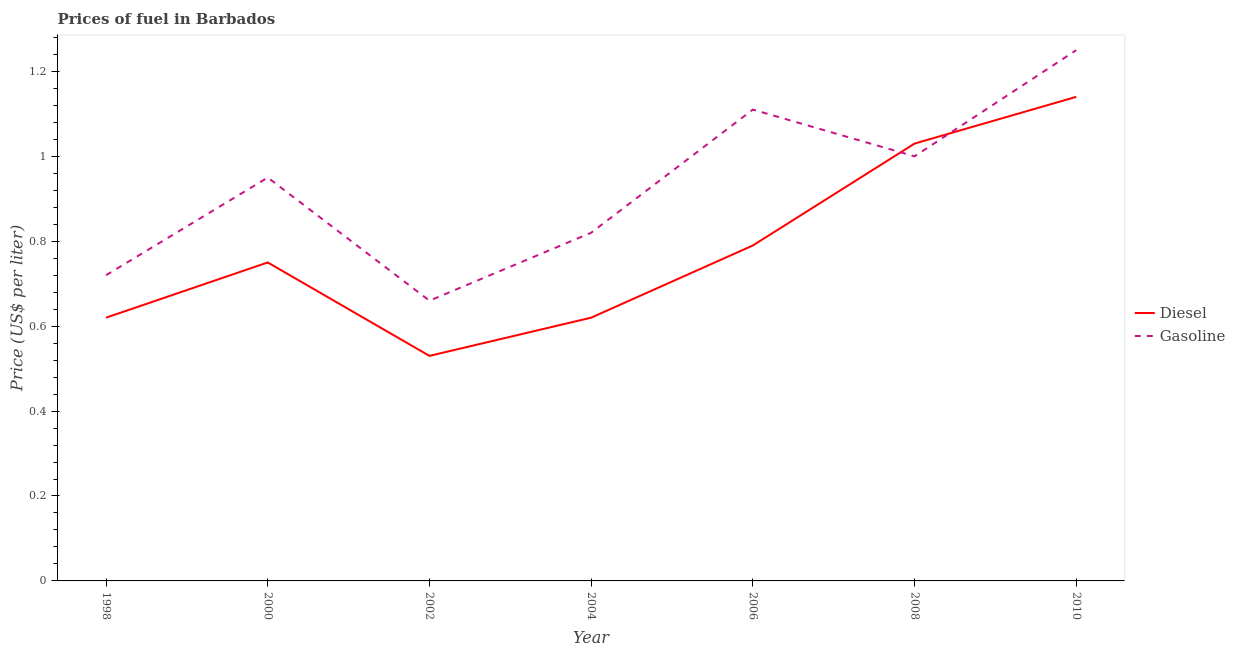How many different coloured lines are there?
Provide a succinct answer. 2. Does the line corresponding to gasoline price intersect with the line corresponding to diesel price?
Keep it short and to the point. Yes. What is the gasoline price in 2008?
Your answer should be very brief. 1. Across all years, what is the maximum diesel price?
Offer a terse response. 1.14. Across all years, what is the minimum diesel price?
Your answer should be compact. 0.53. What is the total diesel price in the graph?
Make the answer very short. 5.48. What is the difference between the diesel price in 2006 and that in 2010?
Provide a short and direct response. -0.35. What is the difference between the diesel price in 2006 and the gasoline price in 2008?
Your answer should be compact. -0.21. What is the average diesel price per year?
Your answer should be compact. 0.78. In the year 2000, what is the difference between the gasoline price and diesel price?
Ensure brevity in your answer.  0.2. In how many years, is the gasoline price greater than 1.04 US$ per litre?
Ensure brevity in your answer.  2. What is the ratio of the diesel price in 2000 to that in 2008?
Offer a very short reply. 0.73. Is the diesel price in 2004 less than that in 2006?
Offer a very short reply. Yes. Is the difference between the gasoline price in 2002 and 2010 greater than the difference between the diesel price in 2002 and 2010?
Ensure brevity in your answer.  Yes. What is the difference between the highest and the second highest gasoline price?
Make the answer very short. 0.14. What is the difference between the highest and the lowest gasoline price?
Your answer should be compact. 0.59. In how many years, is the gasoline price greater than the average gasoline price taken over all years?
Offer a terse response. 4. Is the gasoline price strictly greater than the diesel price over the years?
Offer a terse response. No. Is the gasoline price strictly less than the diesel price over the years?
Your answer should be very brief. No. How many lines are there?
Make the answer very short. 2. How many years are there in the graph?
Ensure brevity in your answer.  7. What is the difference between two consecutive major ticks on the Y-axis?
Offer a very short reply. 0.2. Are the values on the major ticks of Y-axis written in scientific E-notation?
Keep it short and to the point. No. Does the graph contain grids?
Give a very brief answer. No. Where does the legend appear in the graph?
Give a very brief answer. Center right. How many legend labels are there?
Make the answer very short. 2. What is the title of the graph?
Your answer should be very brief. Prices of fuel in Barbados. Does "Taxes on exports" appear as one of the legend labels in the graph?
Offer a very short reply. No. What is the label or title of the X-axis?
Ensure brevity in your answer.  Year. What is the label or title of the Y-axis?
Make the answer very short. Price (US$ per liter). What is the Price (US$ per liter) of Diesel in 1998?
Keep it short and to the point. 0.62. What is the Price (US$ per liter) in Gasoline in 1998?
Make the answer very short. 0.72. What is the Price (US$ per liter) in Diesel in 2002?
Provide a succinct answer. 0.53. What is the Price (US$ per liter) in Gasoline in 2002?
Your response must be concise. 0.66. What is the Price (US$ per liter) in Diesel in 2004?
Offer a terse response. 0.62. What is the Price (US$ per liter) of Gasoline in 2004?
Offer a very short reply. 0.82. What is the Price (US$ per liter) in Diesel in 2006?
Offer a very short reply. 0.79. What is the Price (US$ per liter) in Gasoline in 2006?
Make the answer very short. 1.11. What is the Price (US$ per liter) in Diesel in 2010?
Keep it short and to the point. 1.14. What is the Price (US$ per liter) of Gasoline in 2010?
Your response must be concise. 1.25. Across all years, what is the maximum Price (US$ per liter) of Diesel?
Your response must be concise. 1.14. Across all years, what is the maximum Price (US$ per liter) in Gasoline?
Give a very brief answer. 1.25. Across all years, what is the minimum Price (US$ per liter) in Diesel?
Offer a very short reply. 0.53. Across all years, what is the minimum Price (US$ per liter) of Gasoline?
Your answer should be very brief. 0.66. What is the total Price (US$ per liter) in Diesel in the graph?
Give a very brief answer. 5.48. What is the total Price (US$ per liter) of Gasoline in the graph?
Provide a succinct answer. 6.51. What is the difference between the Price (US$ per liter) in Diesel in 1998 and that in 2000?
Your answer should be compact. -0.13. What is the difference between the Price (US$ per liter) of Gasoline in 1998 and that in 2000?
Provide a succinct answer. -0.23. What is the difference between the Price (US$ per liter) of Diesel in 1998 and that in 2002?
Your response must be concise. 0.09. What is the difference between the Price (US$ per liter) of Diesel in 1998 and that in 2006?
Give a very brief answer. -0.17. What is the difference between the Price (US$ per liter) of Gasoline in 1998 and that in 2006?
Your answer should be very brief. -0.39. What is the difference between the Price (US$ per liter) in Diesel in 1998 and that in 2008?
Provide a short and direct response. -0.41. What is the difference between the Price (US$ per liter) in Gasoline in 1998 and that in 2008?
Provide a short and direct response. -0.28. What is the difference between the Price (US$ per liter) of Diesel in 1998 and that in 2010?
Provide a succinct answer. -0.52. What is the difference between the Price (US$ per liter) in Gasoline in 1998 and that in 2010?
Ensure brevity in your answer.  -0.53. What is the difference between the Price (US$ per liter) of Diesel in 2000 and that in 2002?
Offer a terse response. 0.22. What is the difference between the Price (US$ per liter) in Gasoline in 2000 and that in 2002?
Ensure brevity in your answer.  0.29. What is the difference between the Price (US$ per liter) in Diesel in 2000 and that in 2004?
Your answer should be very brief. 0.13. What is the difference between the Price (US$ per liter) in Gasoline in 2000 and that in 2004?
Your answer should be very brief. 0.13. What is the difference between the Price (US$ per liter) in Diesel in 2000 and that in 2006?
Make the answer very short. -0.04. What is the difference between the Price (US$ per liter) in Gasoline in 2000 and that in 2006?
Keep it short and to the point. -0.16. What is the difference between the Price (US$ per liter) in Diesel in 2000 and that in 2008?
Ensure brevity in your answer.  -0.28. What is the difference between the Price (US$ per liter) in Diesel in 2000 and that in 2010?
Provide a succinct answer. -0.39. What is the difference between the Price (US$ per liter) of Diesel in 2002 and that in 2004?
Offer a terse response. -0.09. What is the difference between the Price (US$ per liter) in Gasoline in 2002 and that in 2004?
Keep it short and to the point. -0.16. What is the difference between the Price (US$ per liter) in Diesel in 2002 and that in 2006?
Give a very brief answer. -0.26. What is the difference between the Price (US$ per liter) in Gasoline in 2002 and that in 2006?
Your answer should be compact. -0.45. What is the difference between the Price (US$ per liter) in Diesel in 2002 and that in 2008?
Keep it short and to the point. -0.5. What is the difference between the Price (US$ per liter) in Gasoline in 2002 and that in 2008?
Provide a succinct answer. -0.34. What is the difference between the Price (US$ per liter) in Diesel in 2002 and that in 2010?
Make the answer very short. -0.61. What is the difference between the Price (US$ per liter) of Gasoline in 2002 and that in 2010?
Your response must be concise. -0.59. What is the difference between the Price (US$ per liter) in Diesel in 2004 and that in 2006?
Your answer should be compact. -0.17. What is the difference between the Price (US$ per liter) of Gasoline in 2004 and that in 2006?
Offer a very short reply. -0.29. What is the difference between the Price (US$ per liter) in Diesel in 2004 and that in 2008?
Offer a very short reply. -0.41. What is the difference between the Price (US$ per liter) of Gasoline in 2004 and that in 2008?
Offer a terse response. -0.18. What is the difference between the Price (US$ per liter) of Diesel in 2004 and that in 2010?
Offer a very short reply. -0.52. What is the difference between the Price (US$ per liter) in Gasoline in 2004 and that in 2010?
Provide a succinct answer. -0.43. What is the difference between the Price (US$ per liter) in Diesel in 2006 and that in 2008?
Provide a short and direct response. -0.24. What is the difference between the Price (US$ per liter) in Gasoline in 2006 and that in 2008?
Give a very brief answer. 0.11. What is the difference between the Price (US$ per liter) of Diesel in 2006 and that in 2010?
Provide a short and direct response. -0.35. What is the difference between the Price (US$ per liter) of Gasoline in 2006 and that in 2010?
Provide a succinct answer. -0.14. What is the difference between the Price (US$ per liter) in Diesel in 2008 and that in 2010?
Give a very brief answer. -0.11. What is the difference between the Price (US$ per liter) in Gasoline in 2008 and that in 2010?
Give a very brief answer. -0.25. What is the difference between the Price (US$ per liter) in Diesel in 1998 and the Price (US$ per liter) in Gasoline in 2000?
Keep it short and to the point. -0.33. What is the difference between the Price (US$ per liter) in Diesel in 1998 and the Price (US$ per liter) in Gasoline in 2002?
Provide a short and direct response. -0.04. What is the difference between the Price (US$ per liter) in Diesel in 1998 and the Price (US$ per liter) in Gasoline in 2004?
Your response must be concise. -0.2. What is the difference between the Price (US$ per liter) in Diesel in 1998 and the Price (US$ per liter) in Gasoline in 2006?
Your response must be concise. -0.49. What is the difference between the Price (US$ per liter) of Diesel in 1998 and the Price (US$ per liter) of Gasoline in 2008?
Your response must be concise. -0.38. What is the difference between the Price (US$ per liter) of Diesel in 1998 and the Price (US$ per liter) of Gasoline in 2010?
Ensure brevity in your answer.  -0.63. What is the difference between the Price (US$ per liter) of Diesel in 2000 and the Price (US$ per liter) of Gasoline in 2002?
Your response must be concise. 0.09. What is the difference between the Price (US$ per liter) of Diesel in 2000 and the Price (US$ per liter) of Gasoline in 2004?
Provide a short and direct response. -0.07. What is the difference between the Price (US$ per liter) of Diesel in 2000 and the Price (US$ per liter) of Gasoline in 2006?
Provide a short and direct response. -0.36. What is the difference between the Price (US$ per liter) in Diesel in 2002 and the Price (US$ per liter) in Gasoline in 2004?
Make the answer very short. -0.29. What is the difference between the Price (US$ per liter) of Diesel in 2002 and the Price (US$ per liter) of Gasoline in 2006?
Provide a succinct answer. -0.58. What is the difference between the Price (US$ per liter) of Diesel in 2002 and the Price (US$ per liter) of Gasoline in 2008?
Give a very brief answer. -0.47. What is the difference between the Price (US$ per liter) in Diesel in 2002 and the Price (US$ per liter) in Gasoline in 2010?
Offer a terse response. -0.72. What is the difference between the Price (US$ per liter) of Diesel in 2004 and the Price (US$ per liter) of Gasoline in 2006?
Keep it short and to the point. -0.49. What is the difference between the Price (US$ per liter) of Diesel in 2004 and the Price (US$ per liter) of Gasoline in 2008?
Give a very brief answer. -0.38. What is the difference between the Price (US$ per liter) of Diesel in 2004 and the Price (US$ per liter) of Gasoline in 2010?
Offer a terse response. -0.63. What is the difference between the Price (US$ per liter) of Diesel in 2006 and the Price (US$ per liter) of Gasoline in 2008?
Your response must be concise. -0.21. What is the difference between the Price (US$ per liter) in Diesel in 2006 and the Price (US$ per liter) in Gasoline in 2010?
Provide a succinct answer. -0.46. What is the difference between the Price (US$ per liter) in Diesel in 2008 and the Price (US$ per liter) in Gasoline in 2010?
Offer a terse response. -0.22. What is the average Price (US$ per liter) of Diesel per year?
Ensure brevity in your answer.  0.78. In the year 2000, what is the difference between the Price (US$ per liter) in Diesel and Price (US$ per liter) in Gasoline?
Your answer should be compact. -0.2. In the year 2002, what is the difference between the Price (US$ per liter) of Diesel and Price (US$ per liter) of Gasoline?
Make the answer very short. -0.13. In the year 2006, what is the difference between the Price (US$ per liter) of Diesel and Price (US$ per liter) of Gasoline?
Provide a succinct answer. -0.32. In the year 2010, what is the difference between the Price (US$ per liter) in Diesel and Price (US$ per liter) in Gasoline?
Keep it short and to the point. -0.11. What is the ratio of the Price (US$ per liter) in Diesel in 1998 to that in 2000?
Ensure brevity in your answer.  0.83. What is the ratio of the Price (US$ per liter) in Gasoline in 1998 to that in 2000?
Give a very brief answer. 0.76. What is the ratio of the Price (US$ per liter) of Diesel in 1998 to that in 2002?
Ensure brevity in your answer.  1.17. What is the ratio of the Price (US$ per liter) in Gasoline in 1998 to that in 2002?
Offer a terse response. 1.09. What is the ratio of the Price (US$ per liter) in Gasoline in 1998 to that in 2004?
Give a very brief answer. 0.88. What is the ratio of the Price (US$ per liter) of Diesel in 1998 to that in 2006?
Ensure brevity in your answer.  0.78. What is the ratio of the Price (US$ per liter) of Gasoline in 1998 to that in 2006?
Your answer should be very brief. 0.65. What is the ratio of the Price (US$ per liter) in Diesel in 1998 to that in 2008?
Provide a succinct answer. 0.6. What is the ratio of the Price (US$ per liter) of Gasoline in 1998 to that in 2008?
Your answer should be very brief. 0.72. What is the ratio of the Price (US$ per liter) of Diesel in 1998 to that in 2010?
Keep it short and to the point. 0.54. What is the ratio of the Price (US$ per liter) in Gasoline in 1998 to that in 2010?
Provide a short and direct response. 0.58. What is the ratio of the Price (US$ per liter) of Diesel in 2000 to that in 2002?
Your answer should be compact. 1.42. What is the ratio of the Price (US$ per liter) of Gasoline in 2000 to that in 2002?
Your response must be concise. 1.44. What is the ratio of the Price (US$ per liter) of Diesel in 2000 to that in 2004?
Provide a short and direct response. 1.21. What is the ratio of the Price (US$ per liter) of Gasoline in 2000 to that in 2004?
Provide a succinct answer. 1.16. What is the ratio of the Price (US$ per liter) of Diesel in 2000 to that in 2006?
Ensure brevity in your answer.  0.95. What is the ratio of the Price (US$ per liter) of Gasoline in 2000 to that in 2006?
Offer a terse response. 0.86. What is the ratio of the Price (US$ per liter) in Diesel in 2000 to that in 2008?
Your response must be concise. 0.73. What is the ratio of the Price (US$ per liter) in Gasoline in 2000 to that in 2008?
Your answer should be very brief. 0.95. What is the ratio of the Price (US$ per liter) in Diesel in 2000 to that in 2010?
Give a very brief answer. 0.66. What is the ratio of the Price (US$ per liter) in Gasoline in 2000 to that in 2010?
Your answer should be compact. 0.76. What is the ratio of the Price (US$ per liter) of Diesel in 2002 to that in 2004?
Your answer should be very brief. 0.85. What is the ratio of the Price (US$ per liter) of Gasoline in 2002 to that in 2004?
Offer a terse response. 0.8. What is the ratio of the Price (US$ per liter) of Diesel in 2002 to that in 2006?
Your answer should be very brief. 0.67. What is the ratio of the Price (US$ per liter) in Gasoline in 2002 to that in 2006?
Offer a terse response. 0.59. What is the ratio of the Price (US$ per liter) of Diesel in 2002 to that in 2008?
Your response must be concise. 0.51. What is the ratio of the Price (US$ per liter) in Gasoline in 2002 to that in 2008?
Ensure brevity in your answer.  0.66. What is the ratio of the Price (US$ per liter) in Diesel in 2002 to that in 2010?
Give a very brief answer. 0.46. What is the ratio of the Price (US$ per liter) in Gasoline in 2002 to that in 2010?
Your answer should be compact. 0.53. What is the ratio of the Price (US$ per liter) in Diesel in 2004 to that in 2006?
Offer a very short reply. 0.78. What is the ratio of the Price (US$ per liter) of Gasoline in 2004 to that in 2006?
Offer a very short reply. 0.74. What is the ratio of the Price (US$ per liter) in Diesel in 2004 to that in 2008?
Make the answer very short. 0.6. What is the ratio of the Price (US$ per liter) of Gasoline in 2004 to that in 2008?
Your response must be concise. 0.82. What is the ratio of the Price (US$ per liter) in Diesel in 2004 to that in 2010?
Give a very brief answer. 0.54. What is the ratio of the Price (US$ per liter) of Gasoline in 2004 to that in 2010?
Keep it short and to the point. 0.66. What is the ratio of the Price (US$ per liter) in Diesel in 2006 to that in 2008?
Offer a very short reply. 0.77. What is the ratio of the Price (US$ per liter) in Gasoline in 2006 to that in 2008?
Provide a succinct answer. 1.11. What is the ratio of the Price (US$ per liter) of Diesel in 2006 to that in 2010?
Provide a succinct answer. 0.69. What is the ratio of the Price (US$ per liter) in Gasoline in 2006 to that in 2010?
Your answer should be compact. 0.89. What is the ratio of the Price (US$ per liter) in Diesel in 2008 to that in 2010?
Provide a short and direct response. 0.9. What is the difference between the highest and the second highest Price (US$ per liter) in Diesel?
Your response must be concise. 0.11. What is the difference between the highest and the second highest Price (US$ per liter) in Gasoline?
Offer a very short reply. 0.14. What is the difference between the highest and the lowest Price (US$ per liter) of Diesel?
Offer a terse response. 0.61. What is the difference between the highest and the lowest Price (US$ per liter) in Gasoline?
Ensure brevity in your answer.  0.59. 